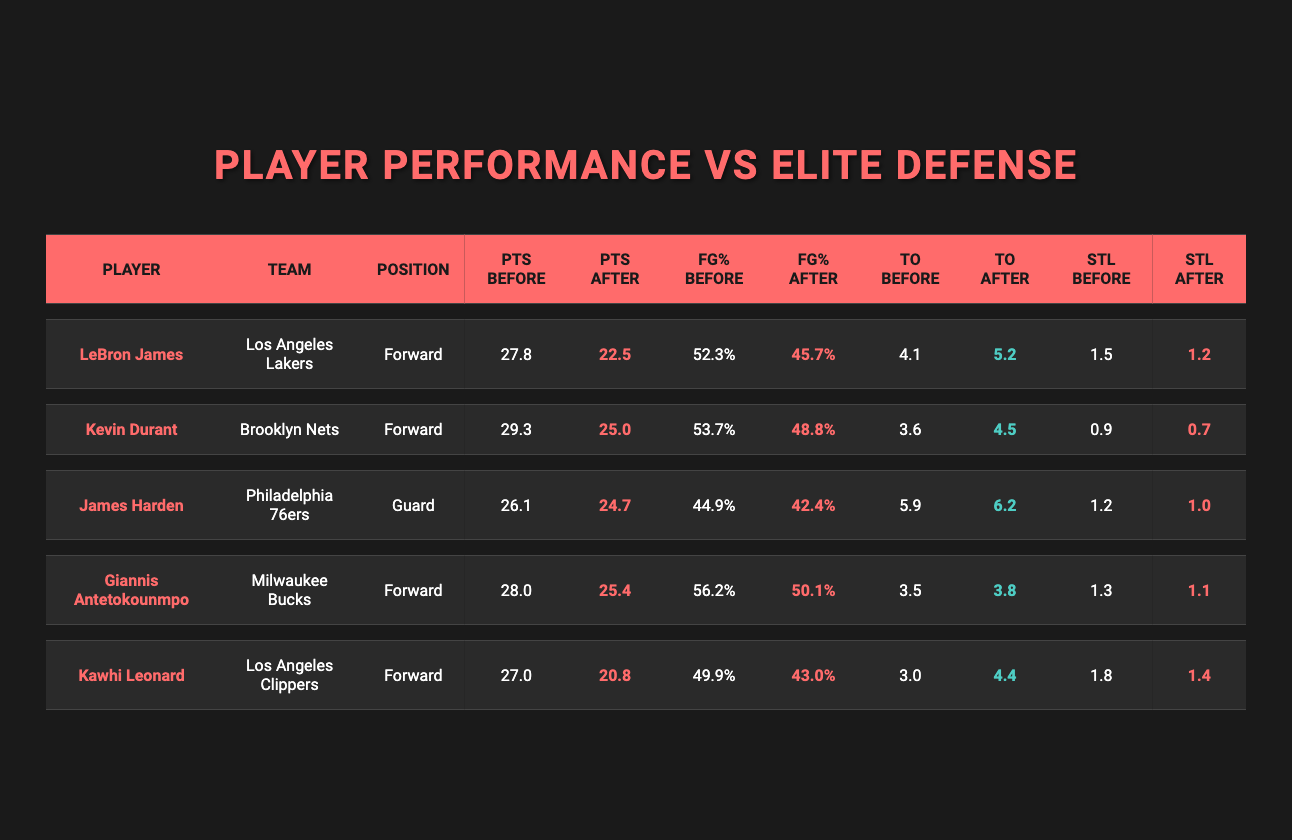What was LeBron James' points per game before facing elite defensive players? By checking the table, in the row for LeBron James, the column labeled "PTS Before" shows his points per game was 27.8 before facing elite defenses.
Answer: 27.8 What team does Giannis Antetokounmpo play for? Referring to the row for Giannis Antetokounmpo in the table, the column labeled "Team" indicates that he plays for the Milwaukee Bucks.
Answer: Milwaukee Bucks How many turnovers per game did Kawhi Leonard have after facing elite defensive players? Looking at the row for Kawhi Leonard, the column labeled "TO After" shows that his turnovers per game increased to 4.4 after facing elite defenses.
Answer: 4.4 What is the difference in James Harden's field goal percentage before and after facing elite defenses? To find the difference, look at James Harden's "FG% Before" (44.9%) and "FG% After" (42.4%). The difference is 44.9 - 42.4 = 2.5%.
Answer: 2.5% Did Kevin Durant's points per game increase after facing elite defensive players? In the table, Kevin Durant's "PTS Before" is 29.3 and "PTS After" is 25.0. Since 25.0 is less than 29.3, his points did not increase; they decreased.
Answer: No What is the average points per game before facing elite defenses for all players listed? To calculate this average, add the points per game before for all players: (27.8 + 29.3 + 26.1 + 28.0 + 27.0) = 138.2. Divide this by the number of players (5), yielding 138.2 / 5 = 27.64.
Answer: 27.64 Which player had the highest field goal percentage before facing elite defensive players? By examining the "FG% Before" column, we see that Giannis Antetokounmpo has the highest value at 56.2%.
Answer: Giannis Antetokounmpo How much did LeBron James' turnovers per game change compared to his performance before facing elite defenses? LeBron's "TO Before" was 4.1 and "TO After" was 5.2. The change is 5.2 - 4.1 = 1.1, indicating an increase in turnovers.
Answer: Increased by 1.1 